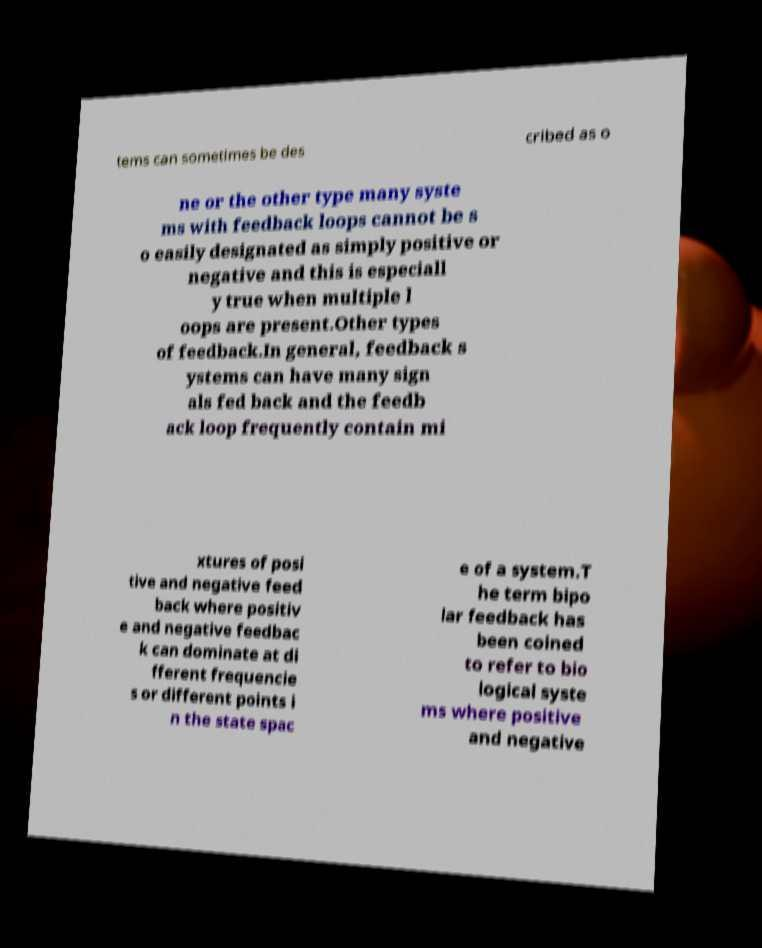I need the written content from this picture converted into text. Can you do that? tems can sometimes be des cribed as o ne or the other type many syste ms with feedback loops cannot be s o easily designated as simply positive or negative and this is especiall y true when multiple l oops are present.Other types of feedback.In general, feedback s ystems can have many sign als fed back and the feedb ack loop frequently contain mi xtures of posi tive and negative feed back where positiv e and negative feedbac k can dominate at di fferent frequencie s or different points i n the state spac e of a system.T he term bipo lar feedback has been coined to refer to bio logical syste ms where positive and negative 